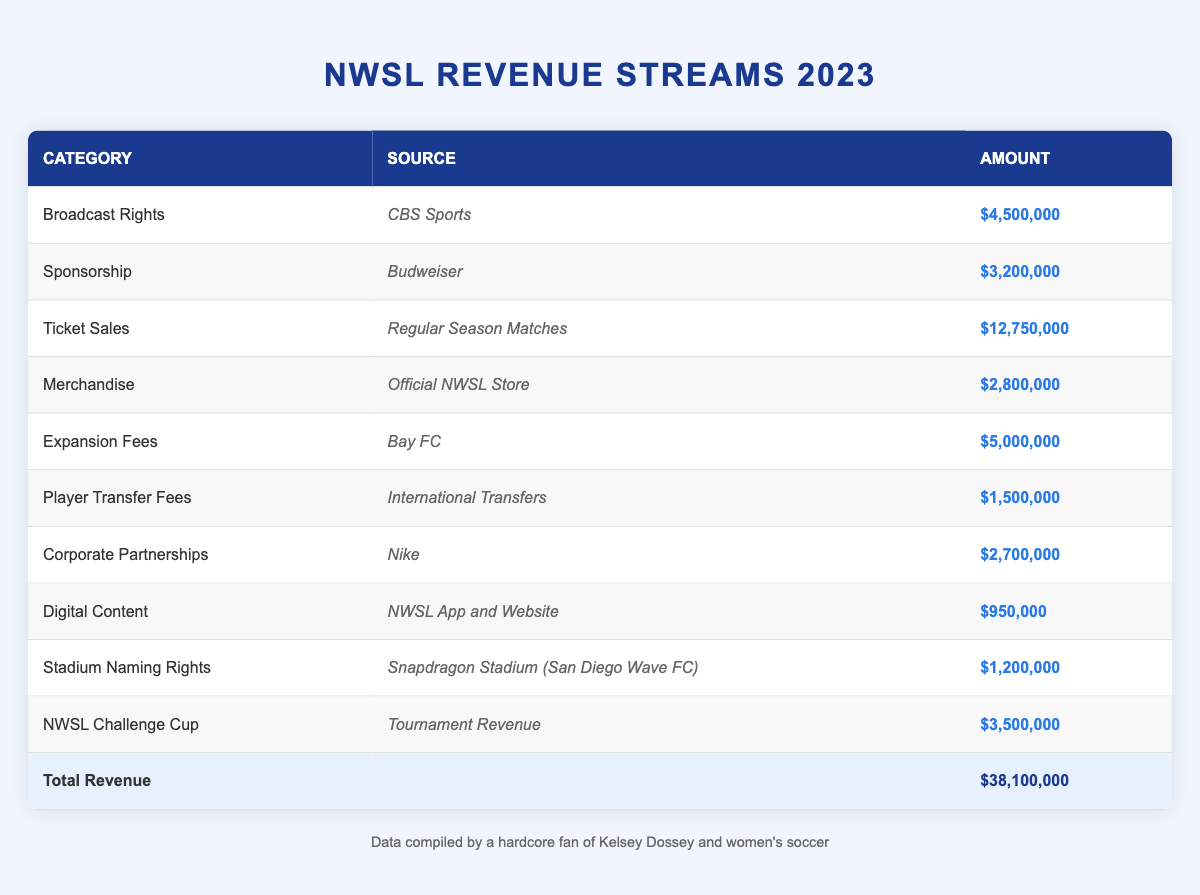What is the total revenue reported for the NWSL in 2023? The total revenue is provided at the bottom of the table in the total row, which shows the amount as $38,100,000.
Answer: $38,100,000 Which revenue source has the highest amount? Looking at the 'Amount' column, the highest value is associated with 'Ticket Sales' for 'Regular Season Matches', which is $12,750,000.
Answer: $12,750,000 Is the revenue from 'Corporate Partnerships' more than the revenue from 'Digital Content'? By comparing the values, 'Corporate Partnerships' is $2,700,000 while 'Digital Content' is $950,000. Since $2,700,000 is greater than $950,000, the statement is true.
Answer: Yes What is the total revenue from 'Expansion Fees' and 'Player Transfer Fees'? First, identify the amounts: 'Expansion Fees' is $5,000,000 and 'Player Transfer Fees' is $1,500,000. The sum is $5,000,000 + $1,500,000 = $6,500,000.
Answer: $6,500,000 How much more revenue does the NWSL make from 'Sponsorship' compared to 'Merchandise'? 'Sponsorship' revenue is $3,200,000 and 'Merchandise' is $2,800,000. The difference is calculated as $3,200,000 - $2,800,000 = $400,000.
Answer: $400,000 What percentage of the total revenue comes from 'Broadcast Rights'? The revenue from 'Broadcast Rights' is $4,500,000. To find the percentage, use the formula: (4,500,000 / 38,100,000) * 100 ≈ 11.8%.
Answer: 11.8% Does the revenue from 'NWSL Challenge Cup' exceed the revenue from 'Stadium Naming Rights'? Comparing the two: 'NWSL Challenge Cup' is $3,500,000 and 'Stadium Naming Rights' is $1,200,000. Since $3,500,000 is greater than $1,200,000, the statement is true.
Answer: Yes What is the combined revenue from 'Digital Content' and 'Stadium Naming Rights'? The revenue from 'Digital Content' is $950,000 and from 'Stadium Naming Rights' is $1,200,000. Adding these gives $950,000 + $1,200,000 = $2,150,000.
Answer: $2,150,000 Which revenue category contributed least to the NWSL's income? The 'Digital Content' category shows the lowest amount at $950,000 when comparing to other revenue sources listed in the table.
Answer: $950,000 